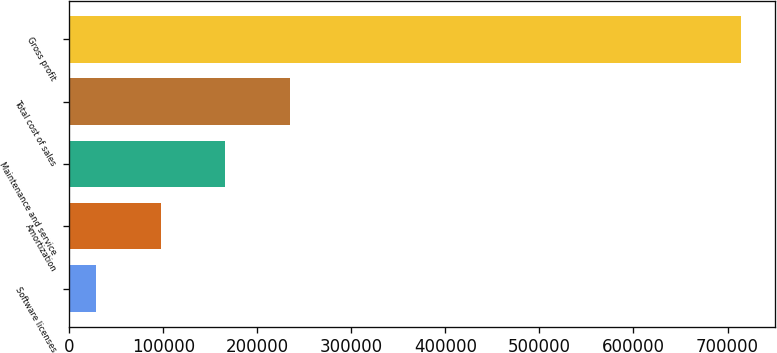<chart> <loc_0><loc_0><loc_500><loc_500><bar_chart><fcel>Software licenses<fcel>Amortization<fcel>Maintenance and service<fcel>Total cost of sales<fcel>Gross profit<nl><fcel>28363<fcel>96983.5<fcel>165604<fcel>234224<fcel>714568<nl></chart> 